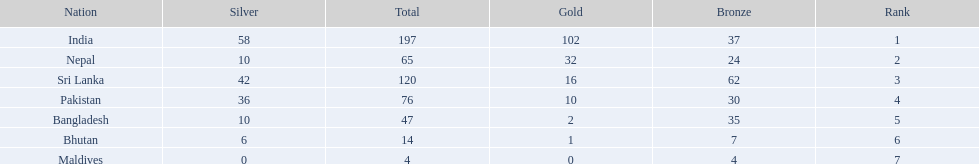Which nations played at the 1999 south asian games? India, Nepal, Sri Lanka, Pakistan, Bangladesh, Bhutan, Maldives. Help me parse the entirety of this table. {'header': ['Nation', 'Silver', 'Total', 'Gold', 'Bronze', 'Rank'], 'rows': [['India', '58', '197', '102', '37', '1'], ['Nepal', '10', '65', '32', '24', '2'], ['Sri Lanka', '42', '120', '16', '62', '3'], ['Pakistan', '36', '76', '10', '30', '4'], ['Bangladesh', '10', '47', '2', '35', '5'], ['Bhutan', '6', '14', '1', '7', '6'], ['Maldives', '0', '4', '0', '4', '7']]} Which country is listed second in the table? Nepal. 